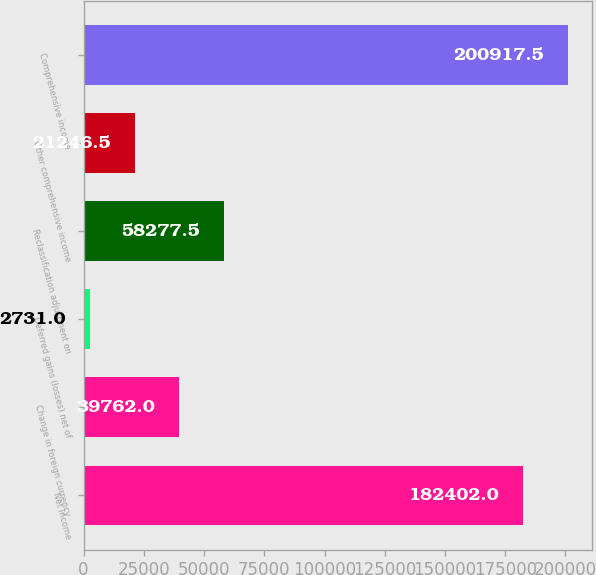<chart> <loc_0><loc_0><loc_500><loc_500><bar_chart><fcel>Net income<fcel>Change in foreign currency<fcel>Deferred gains (losses) net of<fcel>Reclassification adjustment on<fcel>Other comprehensive income<fcel>Comprehensive income<nl><fcel>182402<fcel>39762<fcel>2731<fcel>58277.5<fcel>21246.5<fcel>200918<nl></chart> 